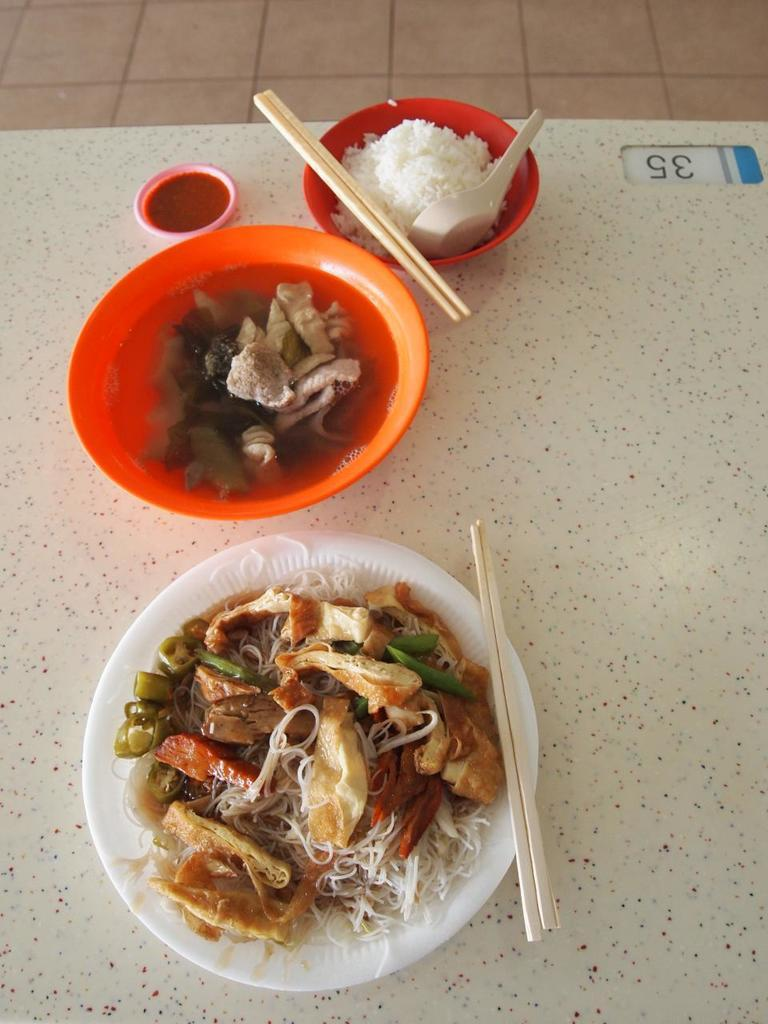How many bowls with food items are visible in the image? There are 3 bowls with food items in the image. What type of utensils are present for eating the food? There are 2 chopsticks and a spoon on the table in the image. What type of lace is used to decorate the table in the image? There is no lace present in the image. 